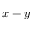Convert formula to latex. <formula><loc_0><loc_0><loc_500><loc_500>x - y</formula> 